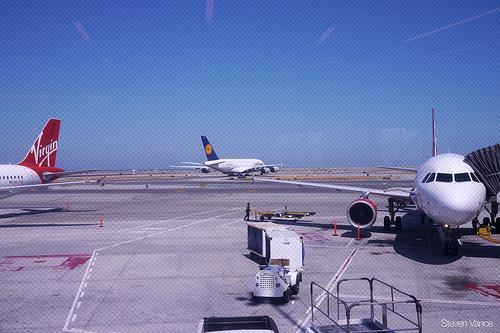How many planes?
Give a very brief answer. 3. 